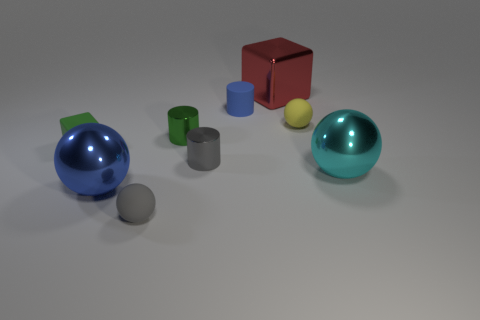What number of large metallic spheres are behind the metal sphere that is on the left side of the tiny thing to the right of the metal cube?
Your answer should be very brief. 1. What number of other gray shiny things have the same shape as the small gray metallic object?
Your answer should be compact. 0. Do the small sphere behind the small gray matte object and the tiny rubber block have the same color?
Offer a very short reply. No. What is the shape of the yellow object that is right of the rubber object that is left of the gray rubber object in front of the big cyan shiny sphere?
Ensure brevity in your answer.  Sphere. There is a green shiny object; does it have the same size as the rubber sphere right of the tiny blue cylinder?
Your answer should be compact. Yes. Is there a blue rubber thing of the same size as the cyan sphere?
Your answer should be compact. No. What number of other things are there of the same material as the green block
Provide a short and direct response. 3. What is the color of the metallic thing that is right of the green shiny thing and behind the tiny green rubber object?
Your answer should be very brief. Red. Is the material of the object behind the small blue rubber object the same as the tiny cylinder behind the small yellow ball?
Offer a terse response. No. There is a cylinder that is in front of the green rubber cube; is it the same size as the cyan sphere?
Keep it short and to the point. No. 